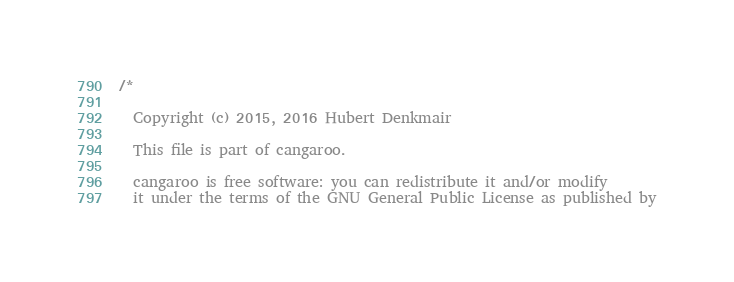<code> <loc_0><loc_0><loc_500><loc_500><_C_>/*

  Copyright (c) 2015, 2016 Hubert Denkmair

  This file is part of cangaroo.

  cangaroo is free software: you can redistribute it and/or modify
  it under the terms of the GNU General Public License as published by</code> 